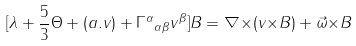<formula> <loc_0><loc_0><loc_500><loc_500>[ \lambda + \frac { 5 } { 3 } { \Theta } + ( a . v ) + { { \Gamma } ^ { \alpha } } _ { { \alpha } { \beta } } v ^ { \beta } ] { B } = { \nabla } { \times } ( v { \times } B ) + { \vec { \omega } } { \times } B</formula> 